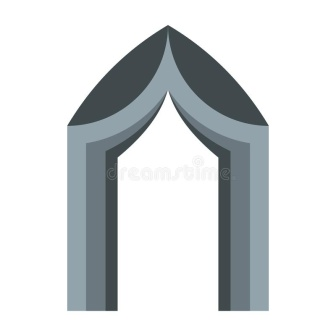Explain the visual content of the image in great detail. The image features a symmetrical, gray archway with a pointed apex, evocative of Gothic architectural design. The archway consists of two robust columns that ascend to converge at the peak of the pointed arch. The structure appears to be crafted from stone or concrete, which conveys a sense of durability and stability. The backdrop is stark white, creating a stark contrast with the gray coloration of the archway. There are no textual elements or other perceivable objects within the image, emphasizing the archway as the central focus. This isolation allows the viewer to fully absorb and appreciate the intricacies of the arch’s design. The simplicity and symmetry of the arch are striking, and while the image does not divulge specific details about the archway’s location or purpose, this ambiguity leaves room for personal interpretation and curiosity. 